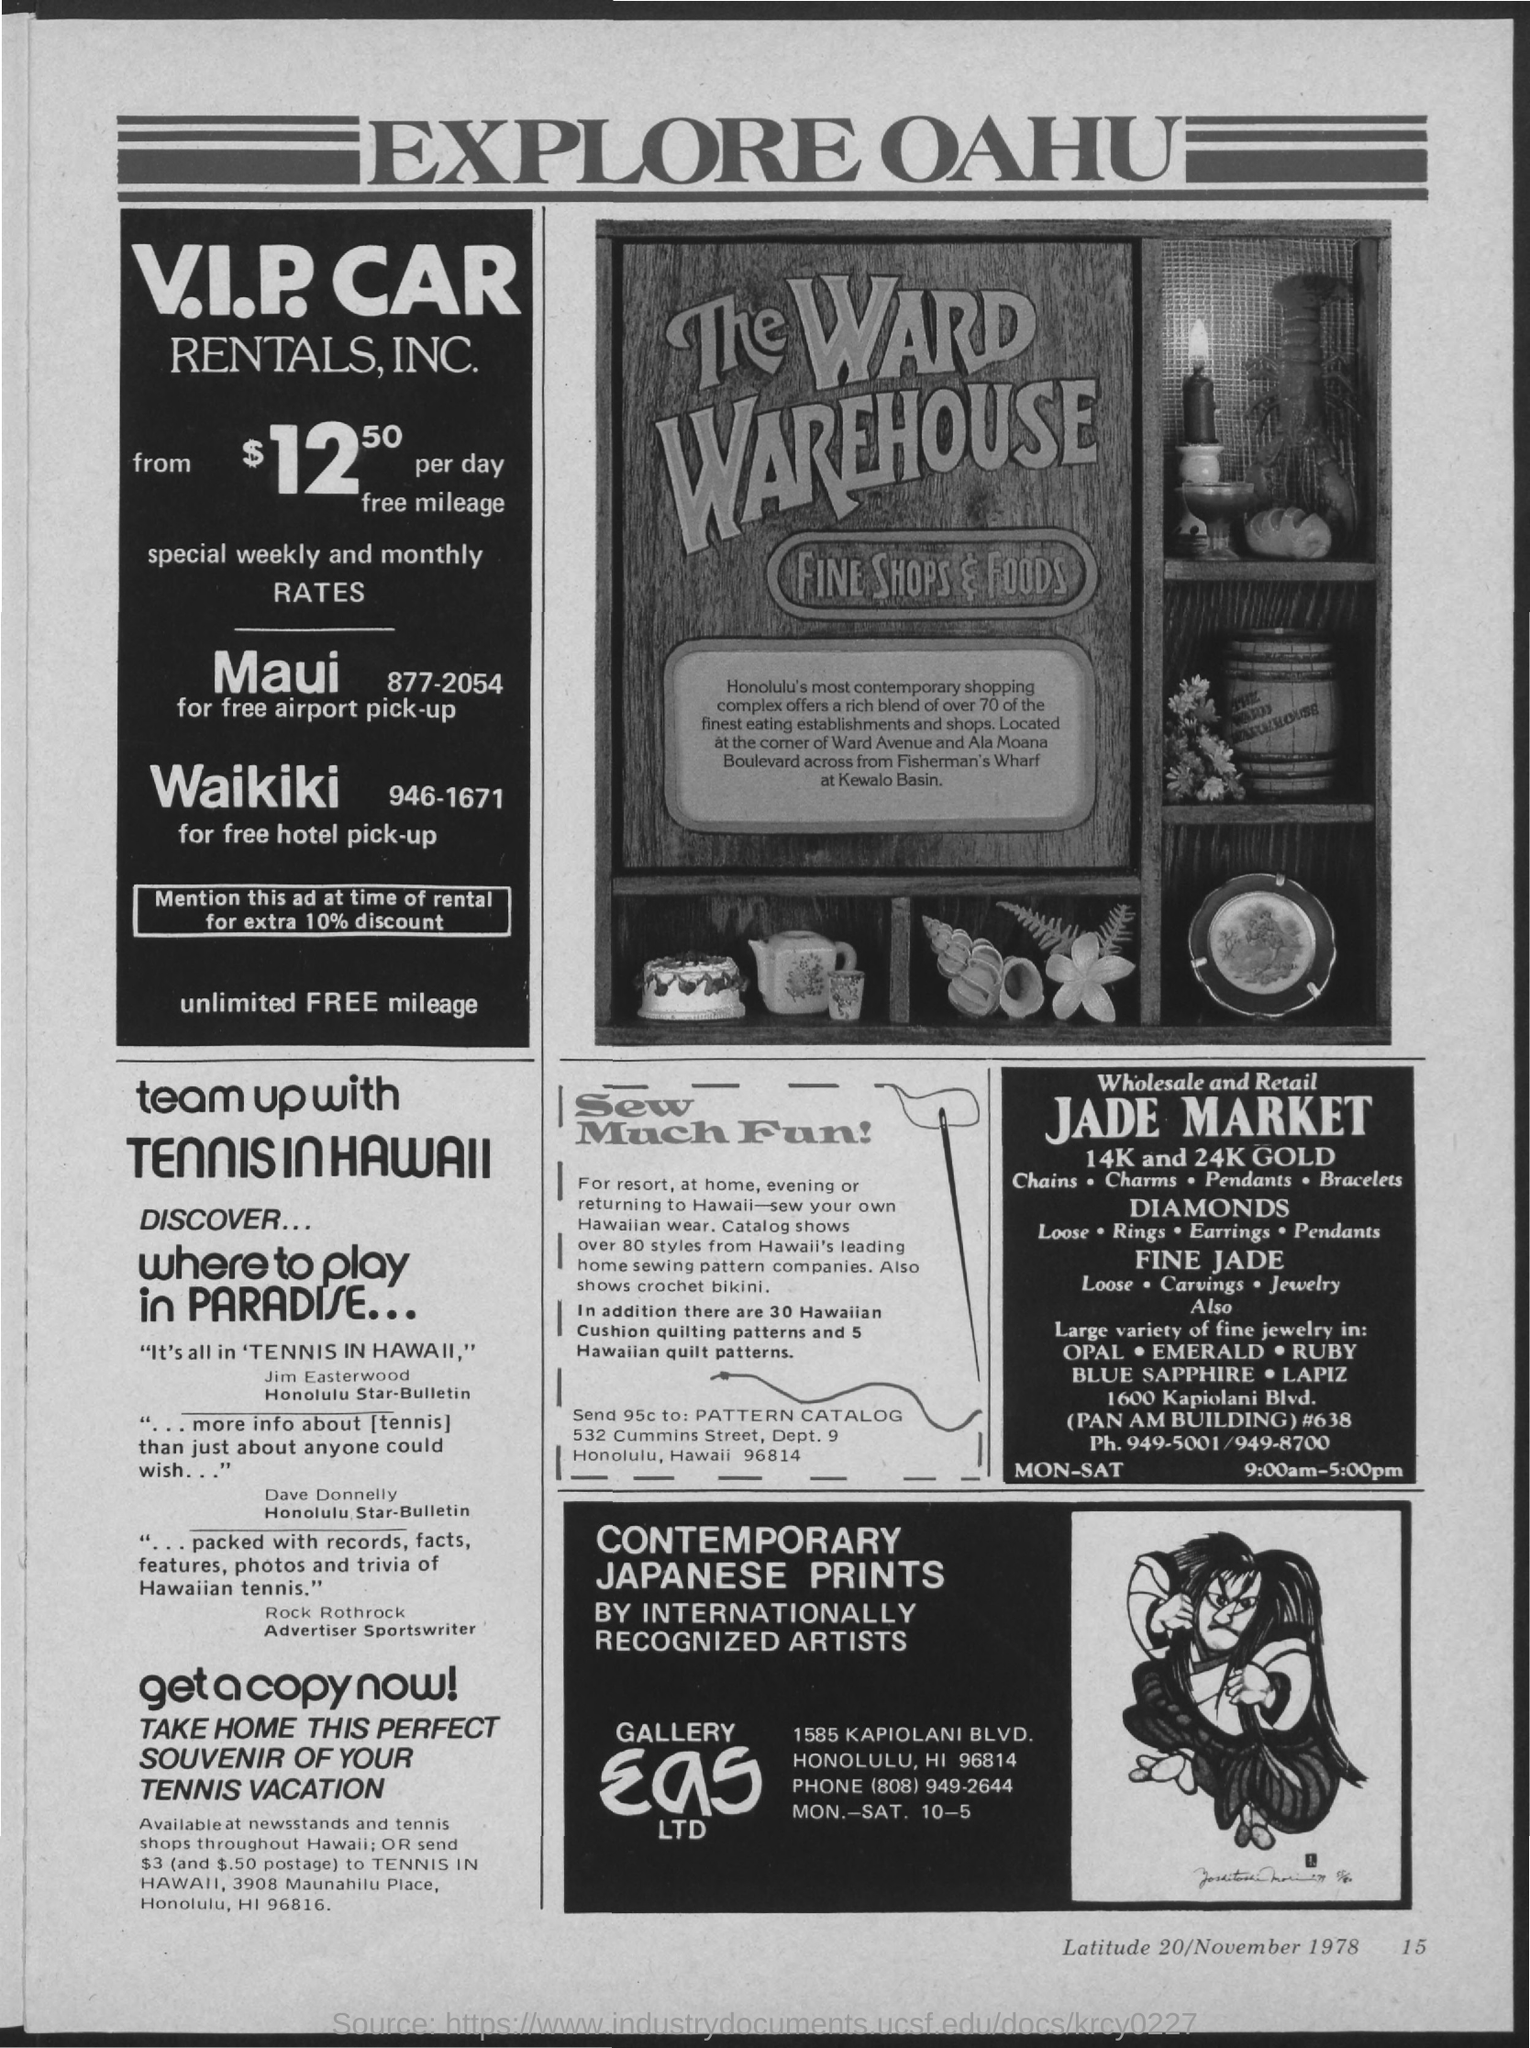What is the heading of advertisement?
Your response must be concise. Explore oahu. 